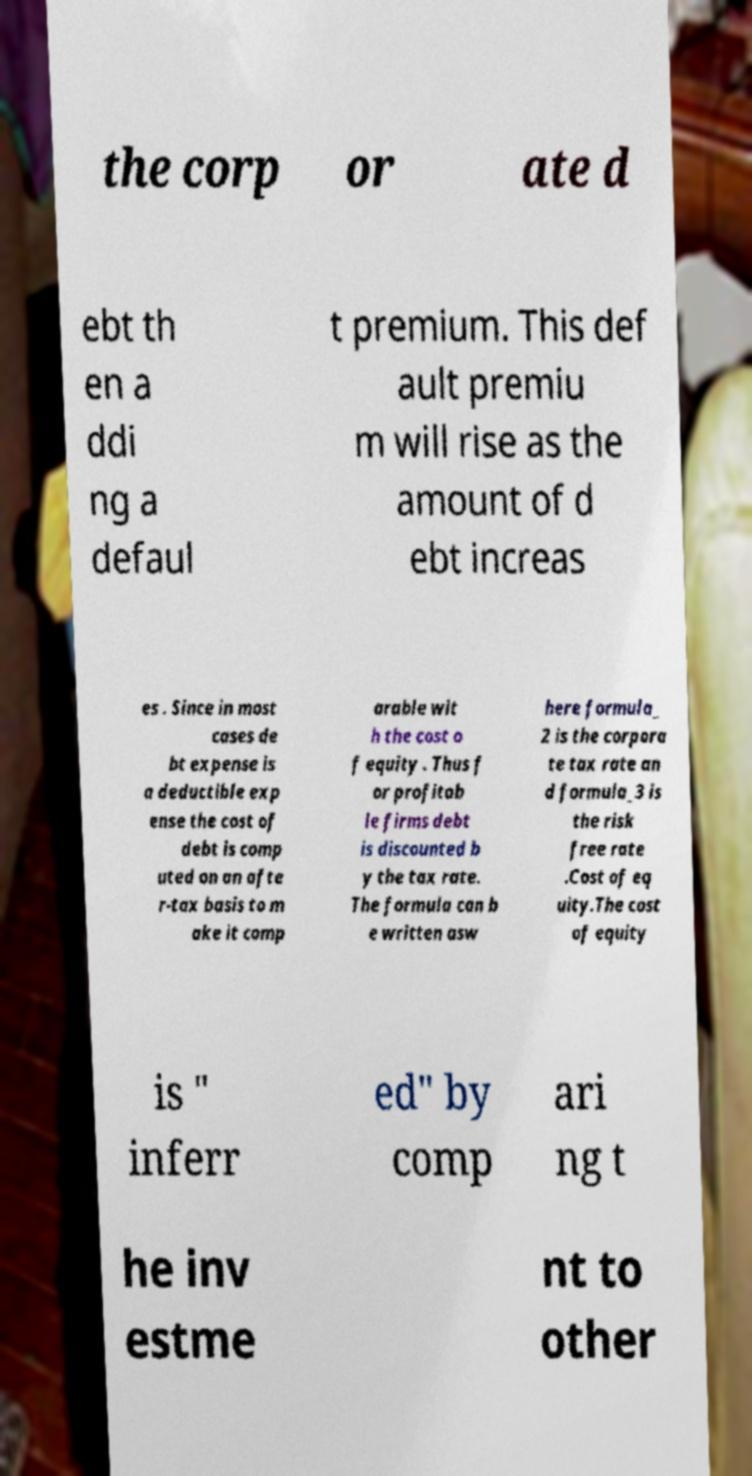I need the written content from this picture converted into text. Can you do that? the corp or ate d ebt th en a ddi ng a defaul t premium. This def ault premiu m will rise as the amount of d ebt increas es . Since in most cases de bt expense is a deductible exp ense the cost of debt is comp uted on an afte r-tax basis to m ake it comp arable wit h the cost o f equity . Thus f or profitab le firms debt is discounted b y the tax rate. The formula can b e written asw here formula_ 2 is the corpora te tax rate an d formula_3 is the risk free rate .Cost of eq uity.The cost of equity is " inferr ed" by comp ari ng t he inv estme nt to other 